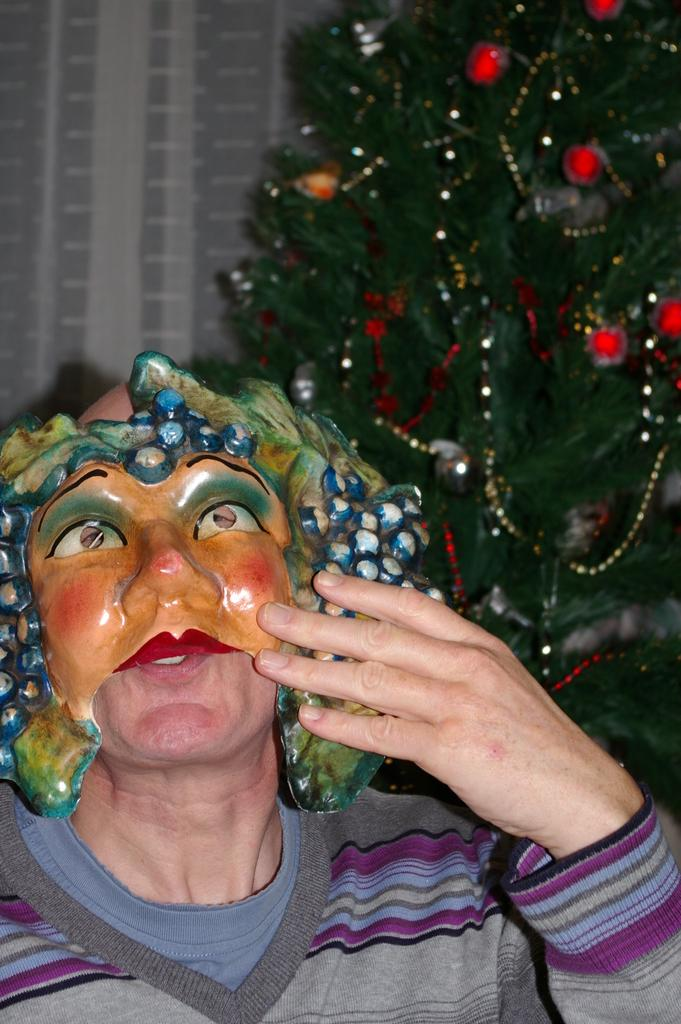Who is present in the image? There is a person in the image. What is the person wearing? The person is wearing a mask. What can be seen in the image besides the person? There is a Christmas tree with lights and objects in the image. What is visible in the background of the image? There is a building in the background of the image. How many chairs are visible in the image? There are no chairs visible in the image; it features a person, a Christmas tree, and a building in the background. 